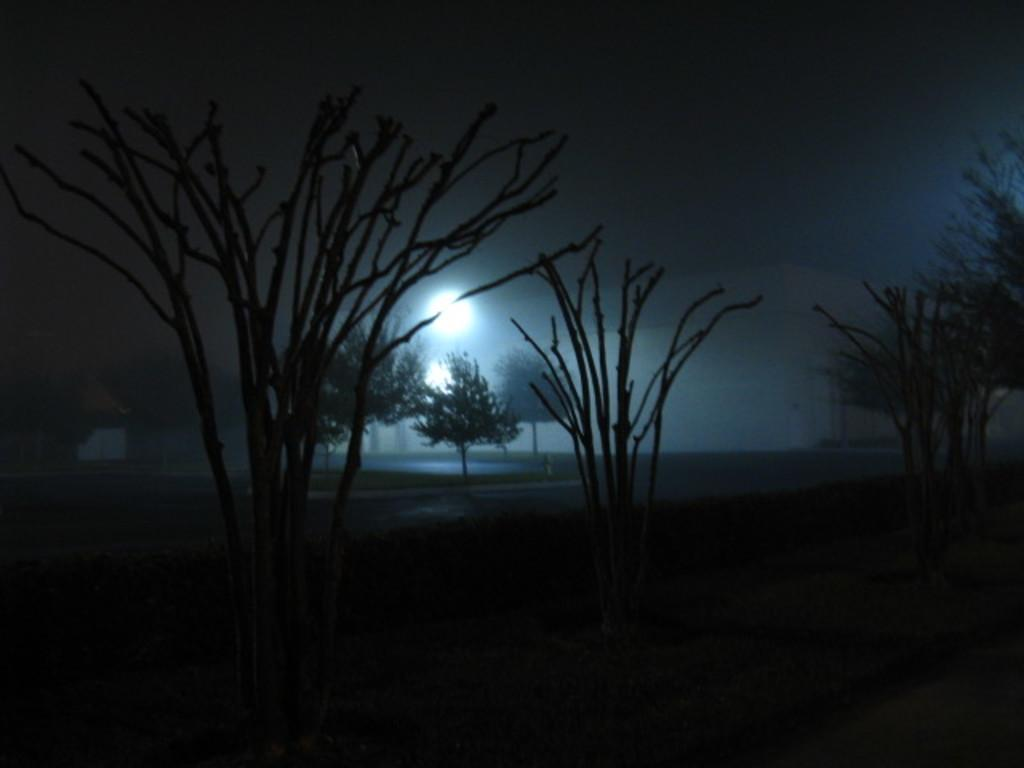What is the overall appearance of the image? The image has a dark appearance. What type of natural elements can be seen in the image? There are trees visible in the image. What type of man-made structure is present in the image? There is a building in the image. Can you describe the source of light in the image? There is a light source in the image. What part of the natural environment is visible in the image? The sky is visible in the image. What type of tin is being used to hold the family gathering in the image? There is no tin or family gathering present in the image. How many boots are arranged on the ground in the image? There are no boots present in the image. 